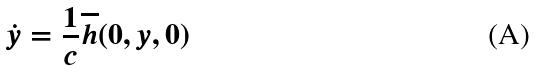Convert formula to latex. <formula><loc_0><loc_0><loc_500><loc_500>\dot { y } = \frac { 1 } { c } \overline { h } ( 0 , y , 0 )</formula> 